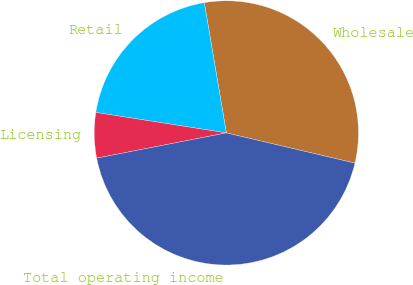<chart> <loc_0><loc_0><loc_500><loc_500><pie_chart><fcel>Wholesale<fcel>Retail<fcel>Licensing<fcel>Total operating income<nl><fcel>31.34%<fcel>19.85%<fcel>5.54%<fcel>43.26%<nl></chart> 